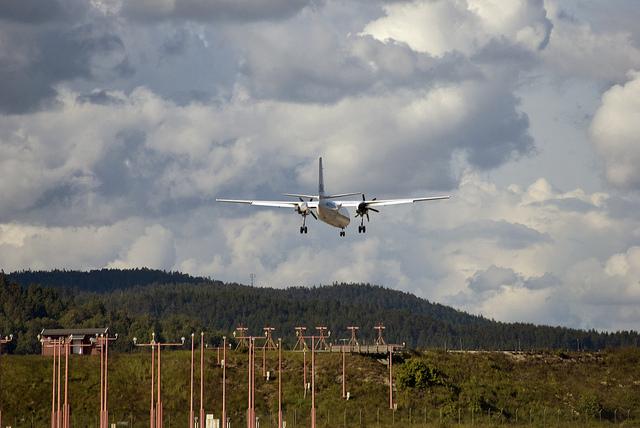What is the plane doing?
Short answer required. Landing. Is the airplane over water?
Quick response, please. No. Is the plane meant to be near water?
Answer briefly. No. Is it cloudy?
Quick response, please. Yes. What are the brown poles and lights for?
Give a very brief answer. Guiding plane. Is it a stormy day?
Quick response, please. No. How many planes are going right?
Short answer required. 1. Is the day overcast?
Quick response, please. Yes. 